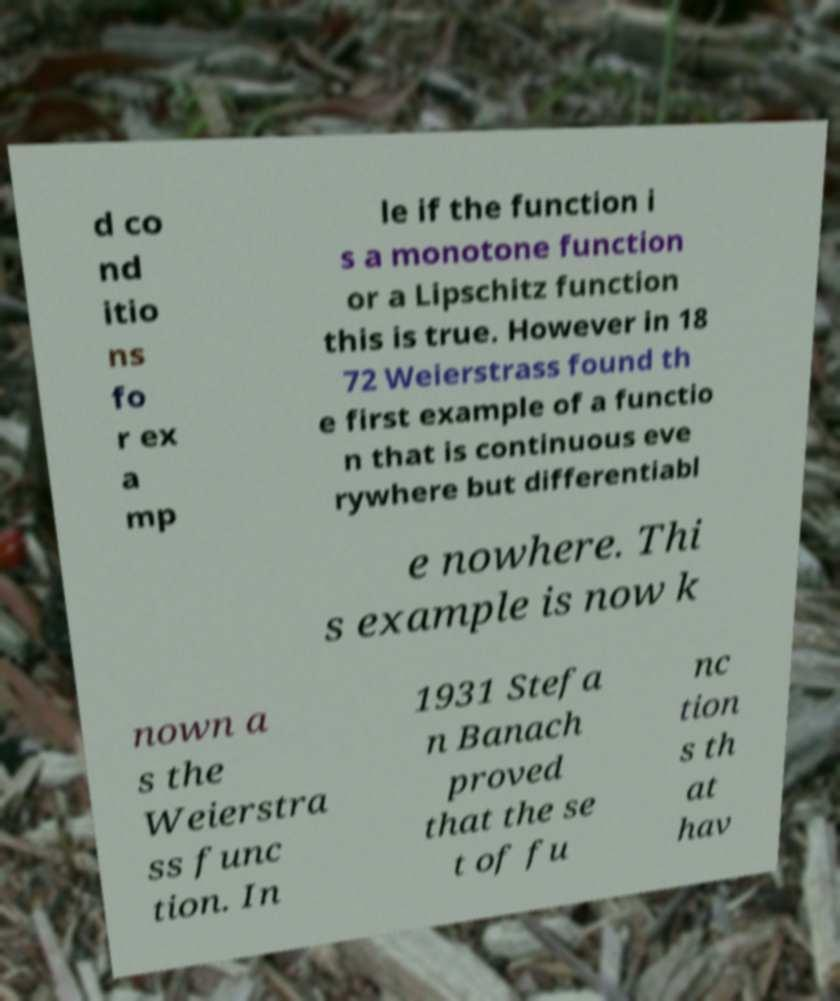Could you assist in decoding the text presented in this image and type it out clearly? d co nd itio ns fo r ex a mp le if the function i s a monotone function or a Lipschitz function this is true. However in 18 72 Weierstrass found th e first example of a functio n that is continuous eve rywhere but differentiabl e nowhere. Thi s example is now k nown a s the Weierstra ss func tion. In 1931 Stefa n Banach proved that the se t of fu nc tion s th at hav 